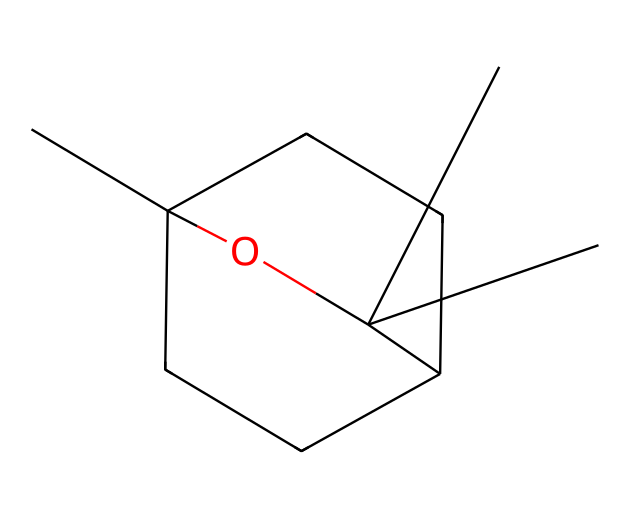What is the name of this chemical? The chemical represented by the SMILES CC12CCC(CC1)C(C)(C)O2 is known as eucalyptol, a monoterpene that is commonly found in essential oils.
Answer: eucalyptol How many carbon atoms are in eucalyptol? In the provided structural formula, counting the carbon atoms presents a total of 10 carbon atoms.
Answer: 10 What functional group is present in eucalyptol? The molecule contains a hydroxyl group (-OH) which indicates that it is an alcohol. This can be identified by the oxygen atom connected to a hydrogen atom in the structure.
Answer: alcohol What type of chemical is eucalyptol known as in terms of flavor and fragrance? Eucalyptol is classified as a flavoring agent and fragrance compound because it is derived from eucalyptus and is used in many perfumes and flavoring products.
Answer: flavoring agent What is the molecular formula of eucalyptol? From the count of carbon, hydrogen, and oxygen in the structural formula, the molecular formula can be derived as C10H18O. This accounts for all the atoms in the structure, including the values we previously assessed.
Answer: C10H18O Which part of eucalyptol contributes to its aromatic properties? The cyclic structure of the chemical, specifically the carbon rings, contributes to its aromatic properties, making it a key component in essential oils known for their soothing smell.
Answer: cyclic structure What makes eucalyptol effective in stress-relief applications? Eucalyptol shows properties that help promote relaxation and relief by having a refreshing scent that is believed to alleviate stress and anxiety. Its structural characteristics aid in vaporizing effectively, enhancing its impact in aromatherapy.
Answer: refreshing scent 